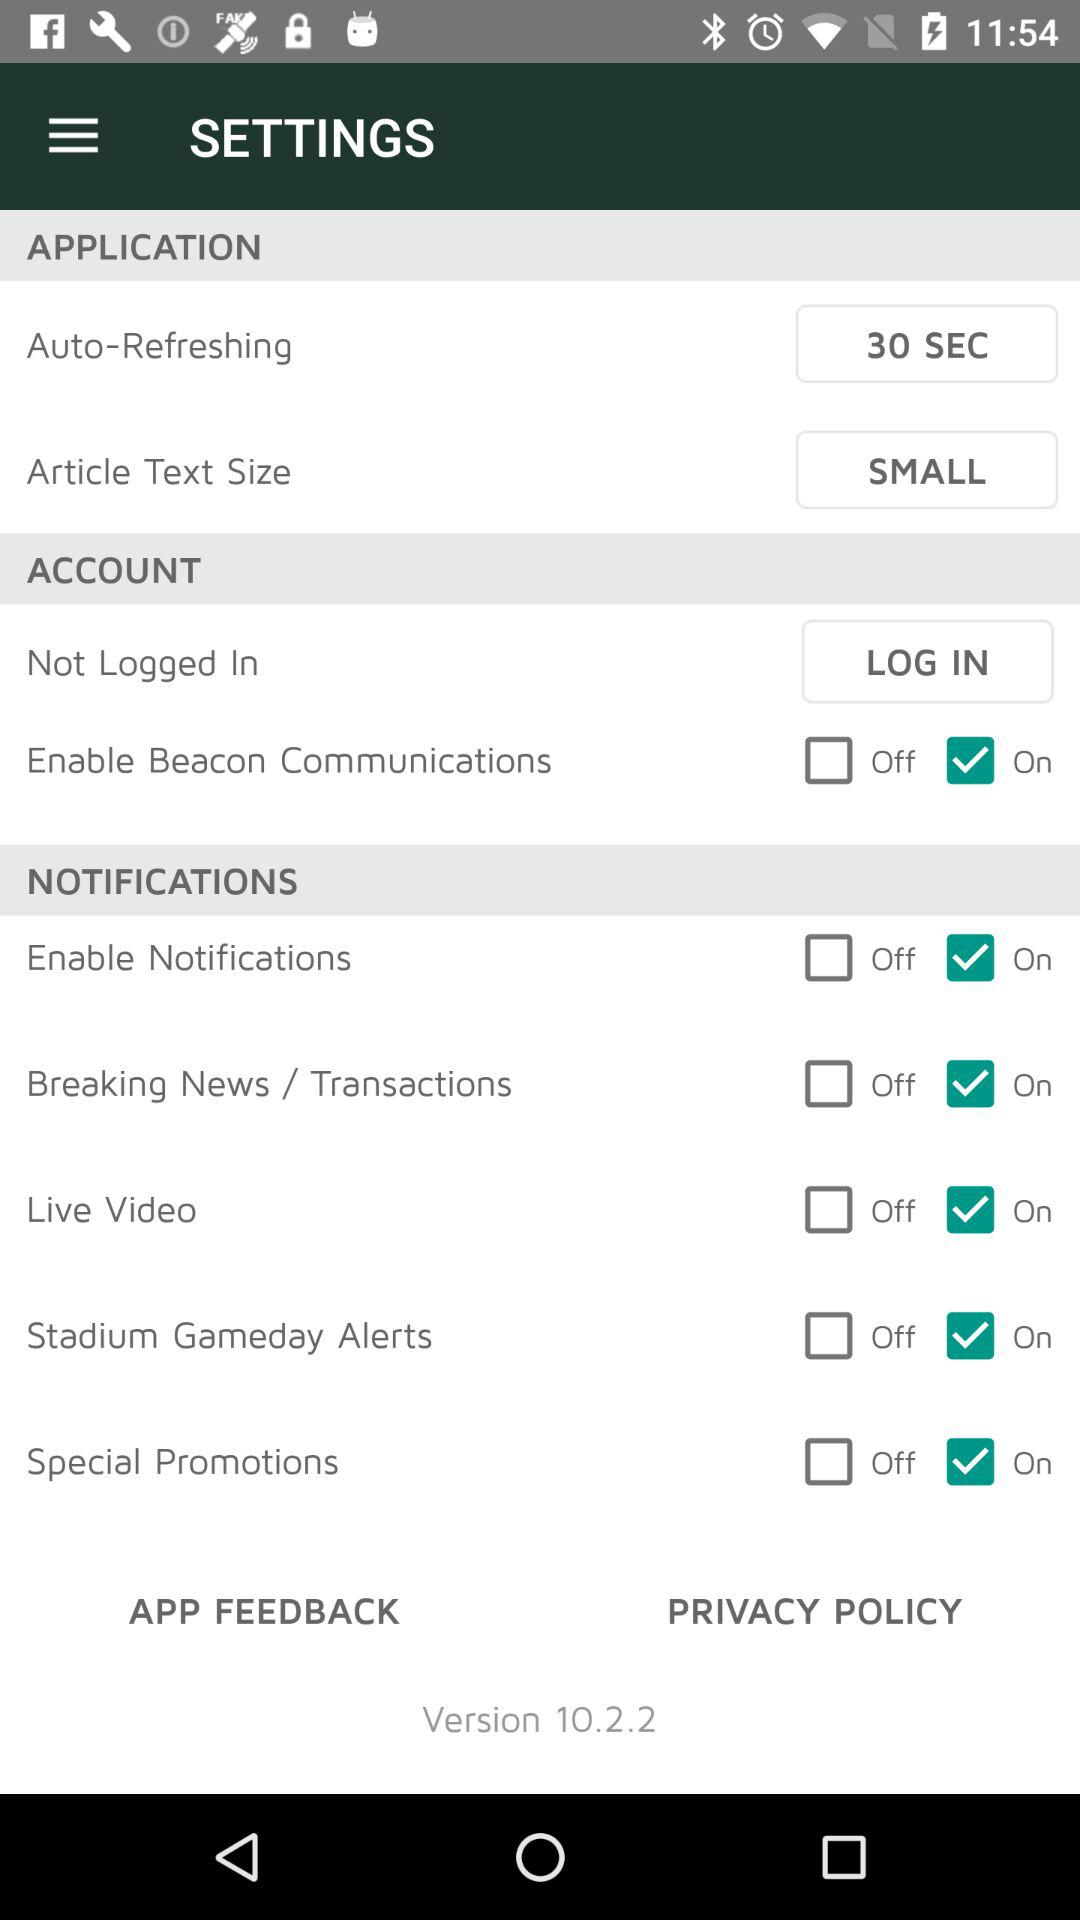What are the names of the options in "NOTIFICATIONS" for which status is ON? The names of the options are "Enable Notifications", "Breaking News / Transactions", "Live Video", "Stadium Gameday Alerts" and "Special Promotions". 